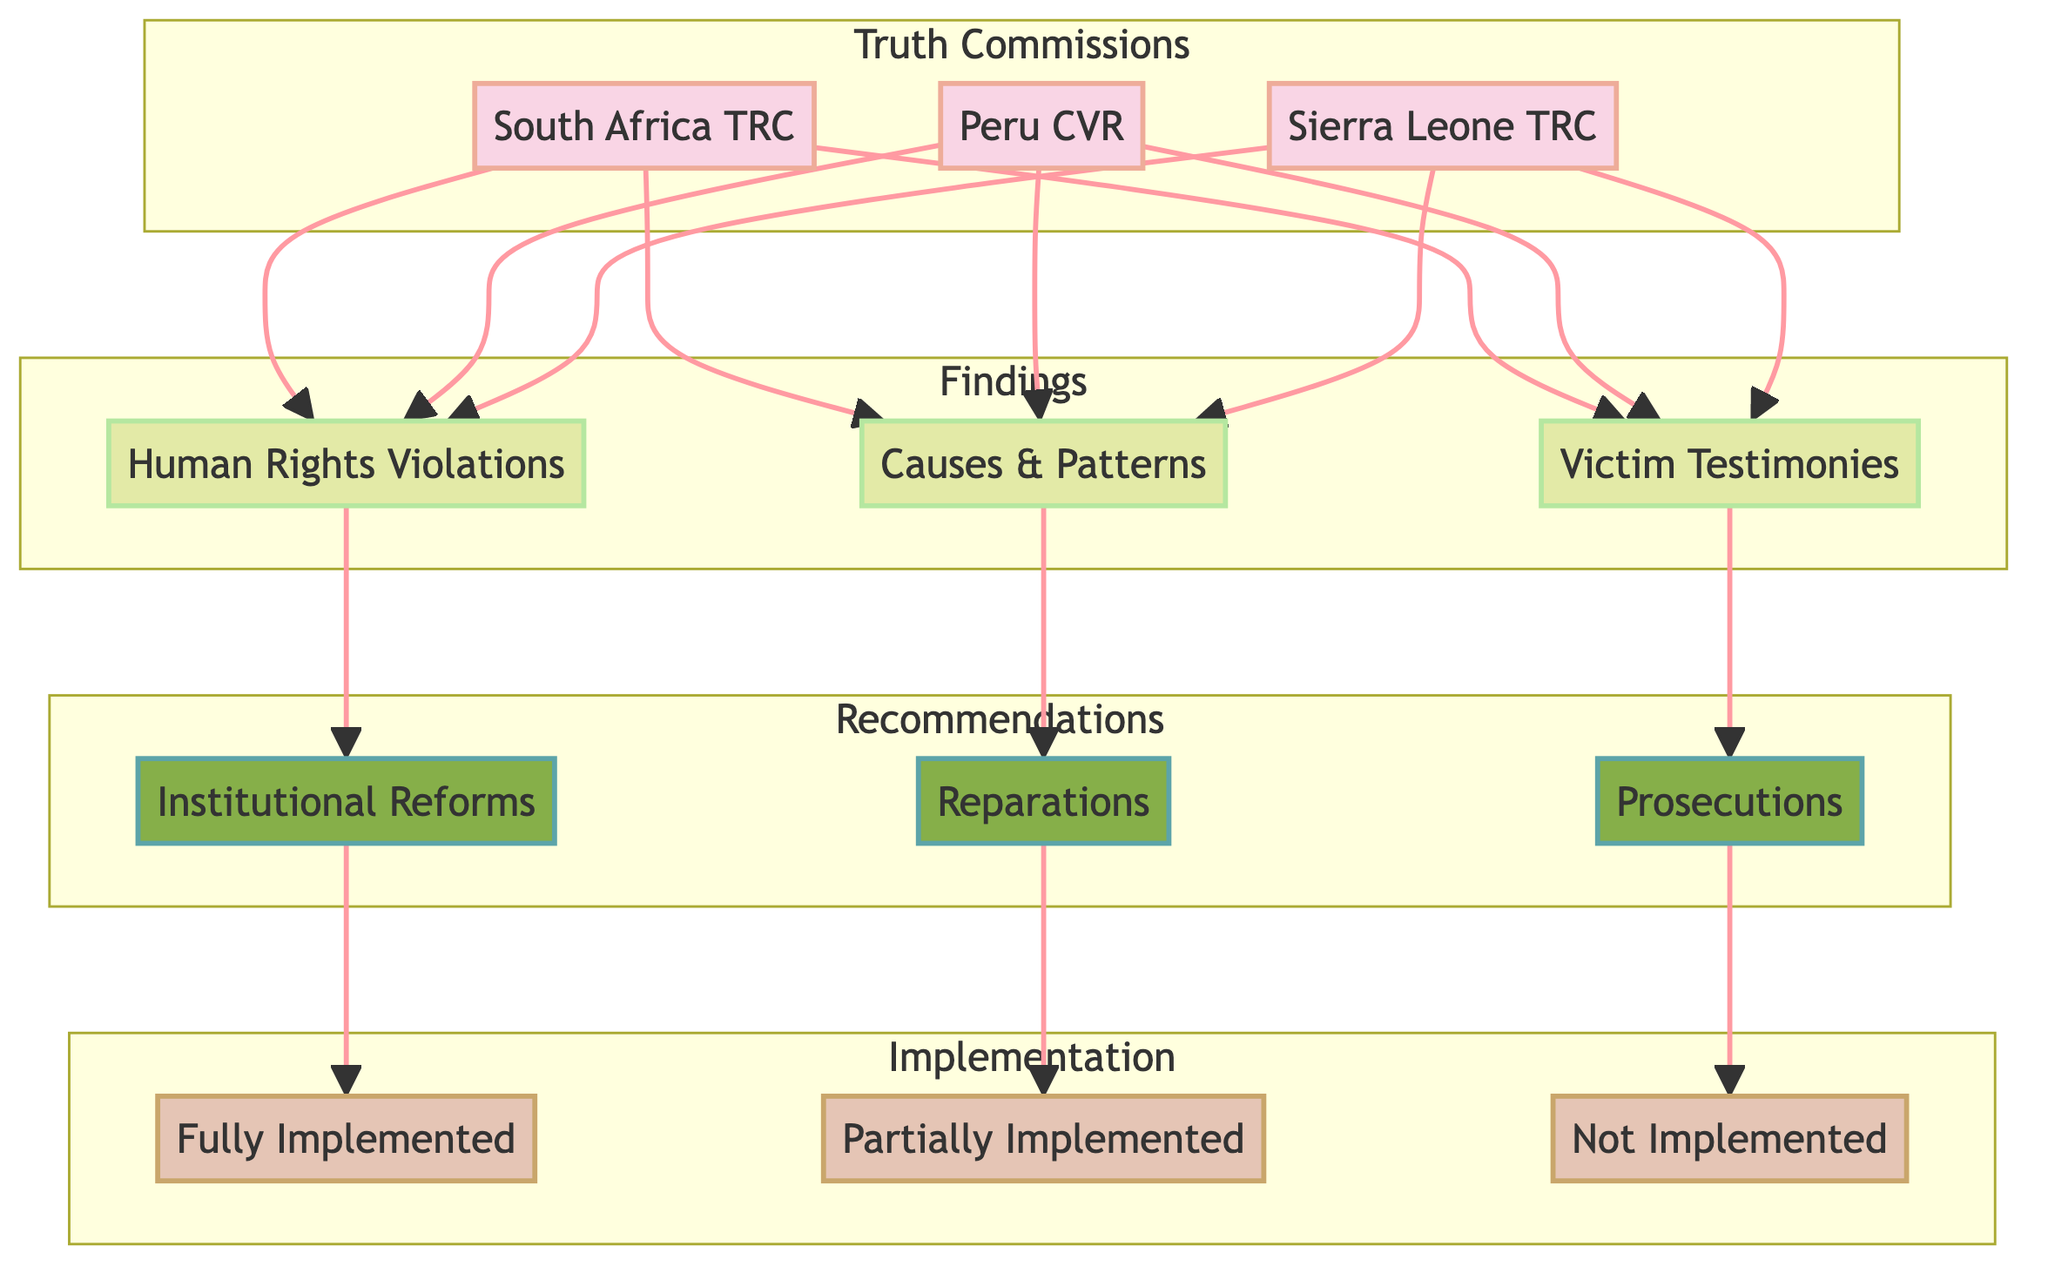What are the three truth commissions depicted in the diagram? The diagram shows three truth commissions: South Africa TRC, Peru CVR, and Sierra Leone TRC. These names are clearly labeled within the "Truth Commissions" subgraph.
Answer: South Africa TRC, Peru CVR, Sierra Leone TRC How many findings are listed in the diagram? There are three findings indicated in the diagram: Human Rights Violations, Causes & Patterns, and Victim Testimonies. These findings are shown under the "Findings" subgraph.
Answer: 3 Which recommendation is connected to Human Rights Violations? The recommendation connected to Human Rights Violations is Institutional Reforms. This is determined by following the connection line from the finding to the respective recommendation node.
Answer: Institutional Reforms What is the implementation status of Reparations? The implementation status of Reparations is Partially Implemented. This is derived by tracing the connection from `Reparations` to `Partially Implemented` within the diagram's flow.
Answer: Partially Implemented Which truth commission has all its findings leading to recommendations? All three truth commissions (South Africa TRC, Peru CVR, Sierra Leone TRC) have all their findings leading to recommendations. Each commission's findings connect to different recommendations without any drops leading to null values.
Answer: All three What is the specific connection for Victim Testimonies? Victim Testimonies connects specifically to the recommendation of Prosecutions, seen directly in the diagram where this finding flows into this recommendation node.
Answer: Prosecutions How many nodes are in the "Implementation" subgraph? There are three nodes in the "Implementation" subgraph: Fully Implemented, Partially Implemented, and Not Implemented. This is counted by looking at the node labels within that specific subgraph.
Answer: 3 Which finding leads to Not Implemented? The finding that leads to Not Implemented is Prosecutions, as indicated by the connection from `Prosecutions` to `Not Implemented` in the diagram.
Answer: Prosecutions How many total edges connect the findings to the recommendations? There are three edges connecting the findings to the recommendations: from Human Rights Violations to Institutional Reforms, from Causes & Patterns to Reparations, and from Victim Testimonies to Prosecutions. This can be counted by examining the lines drawn from findings to their corresponding recommendations.
Answer: 3 